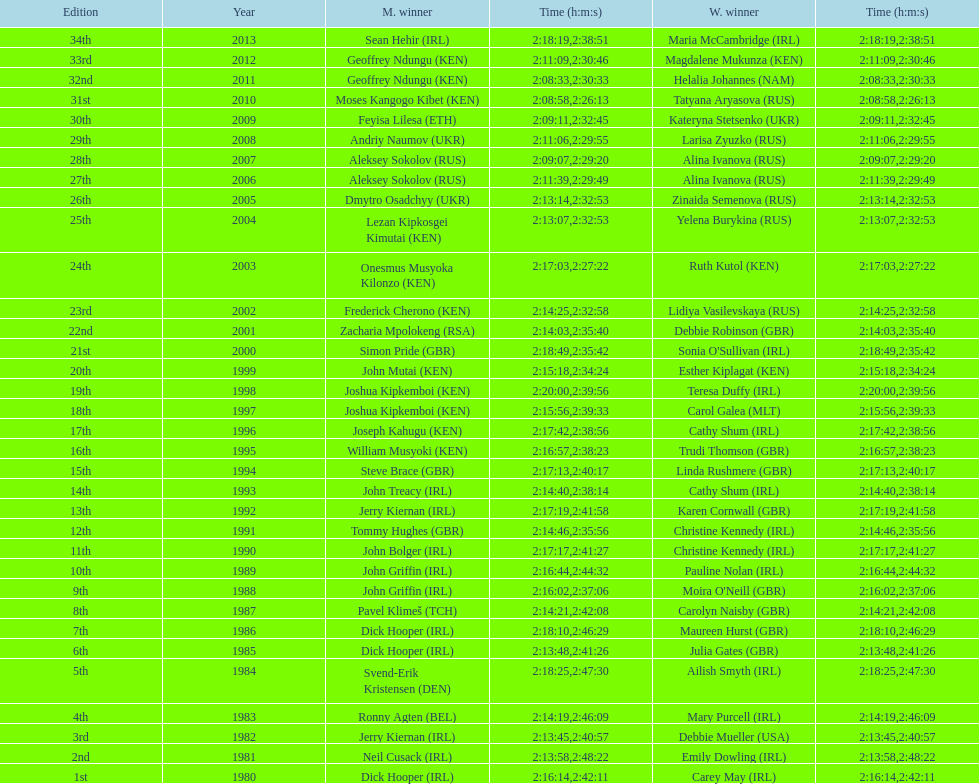In 2009, which competitor finished faster - the male or the female? Male. 